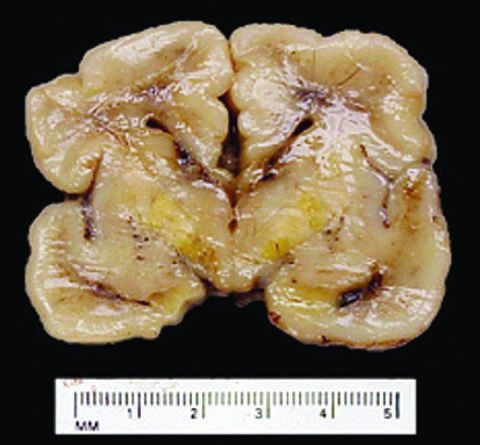re some long-lived resident tissue macrophages less developed in the neonatal period than they are in adulthood?
Answer the question using a single word or phrase. No 